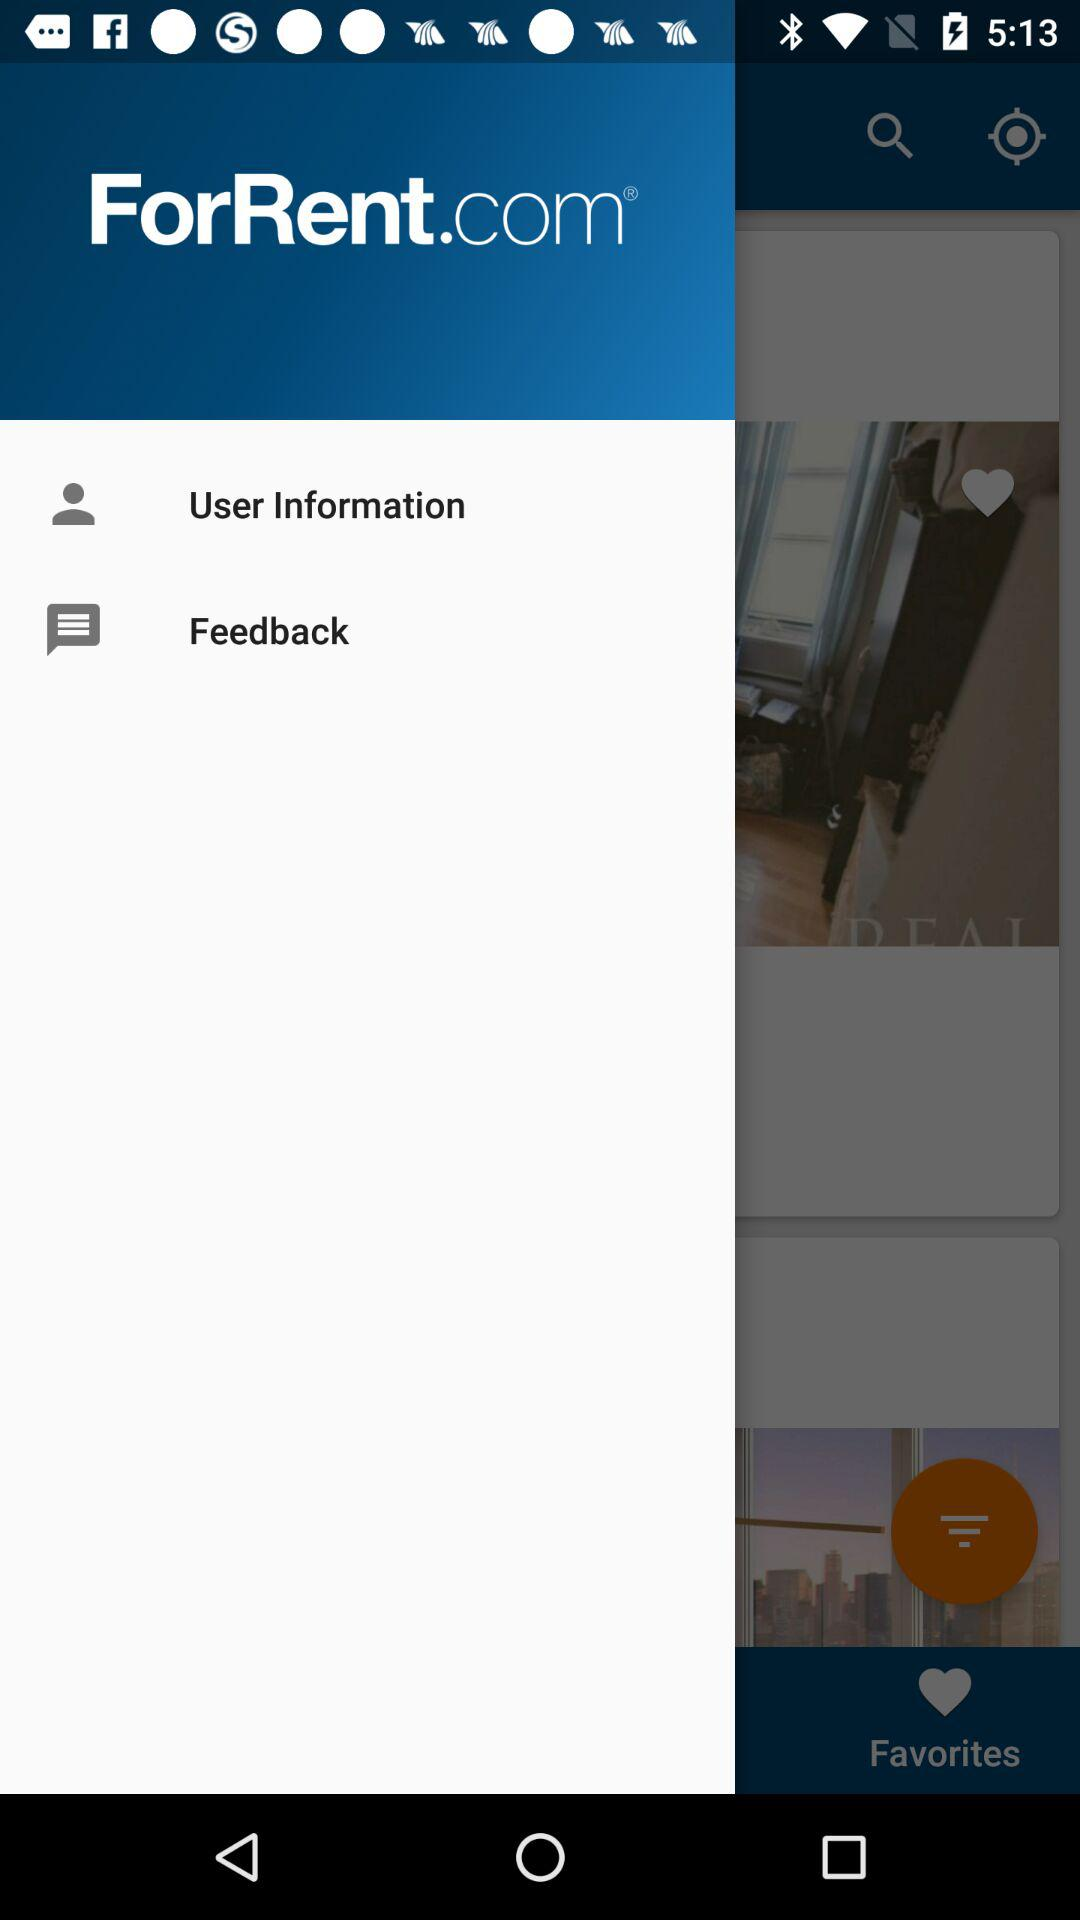What is the application name? The application name is "ForRent.com". 